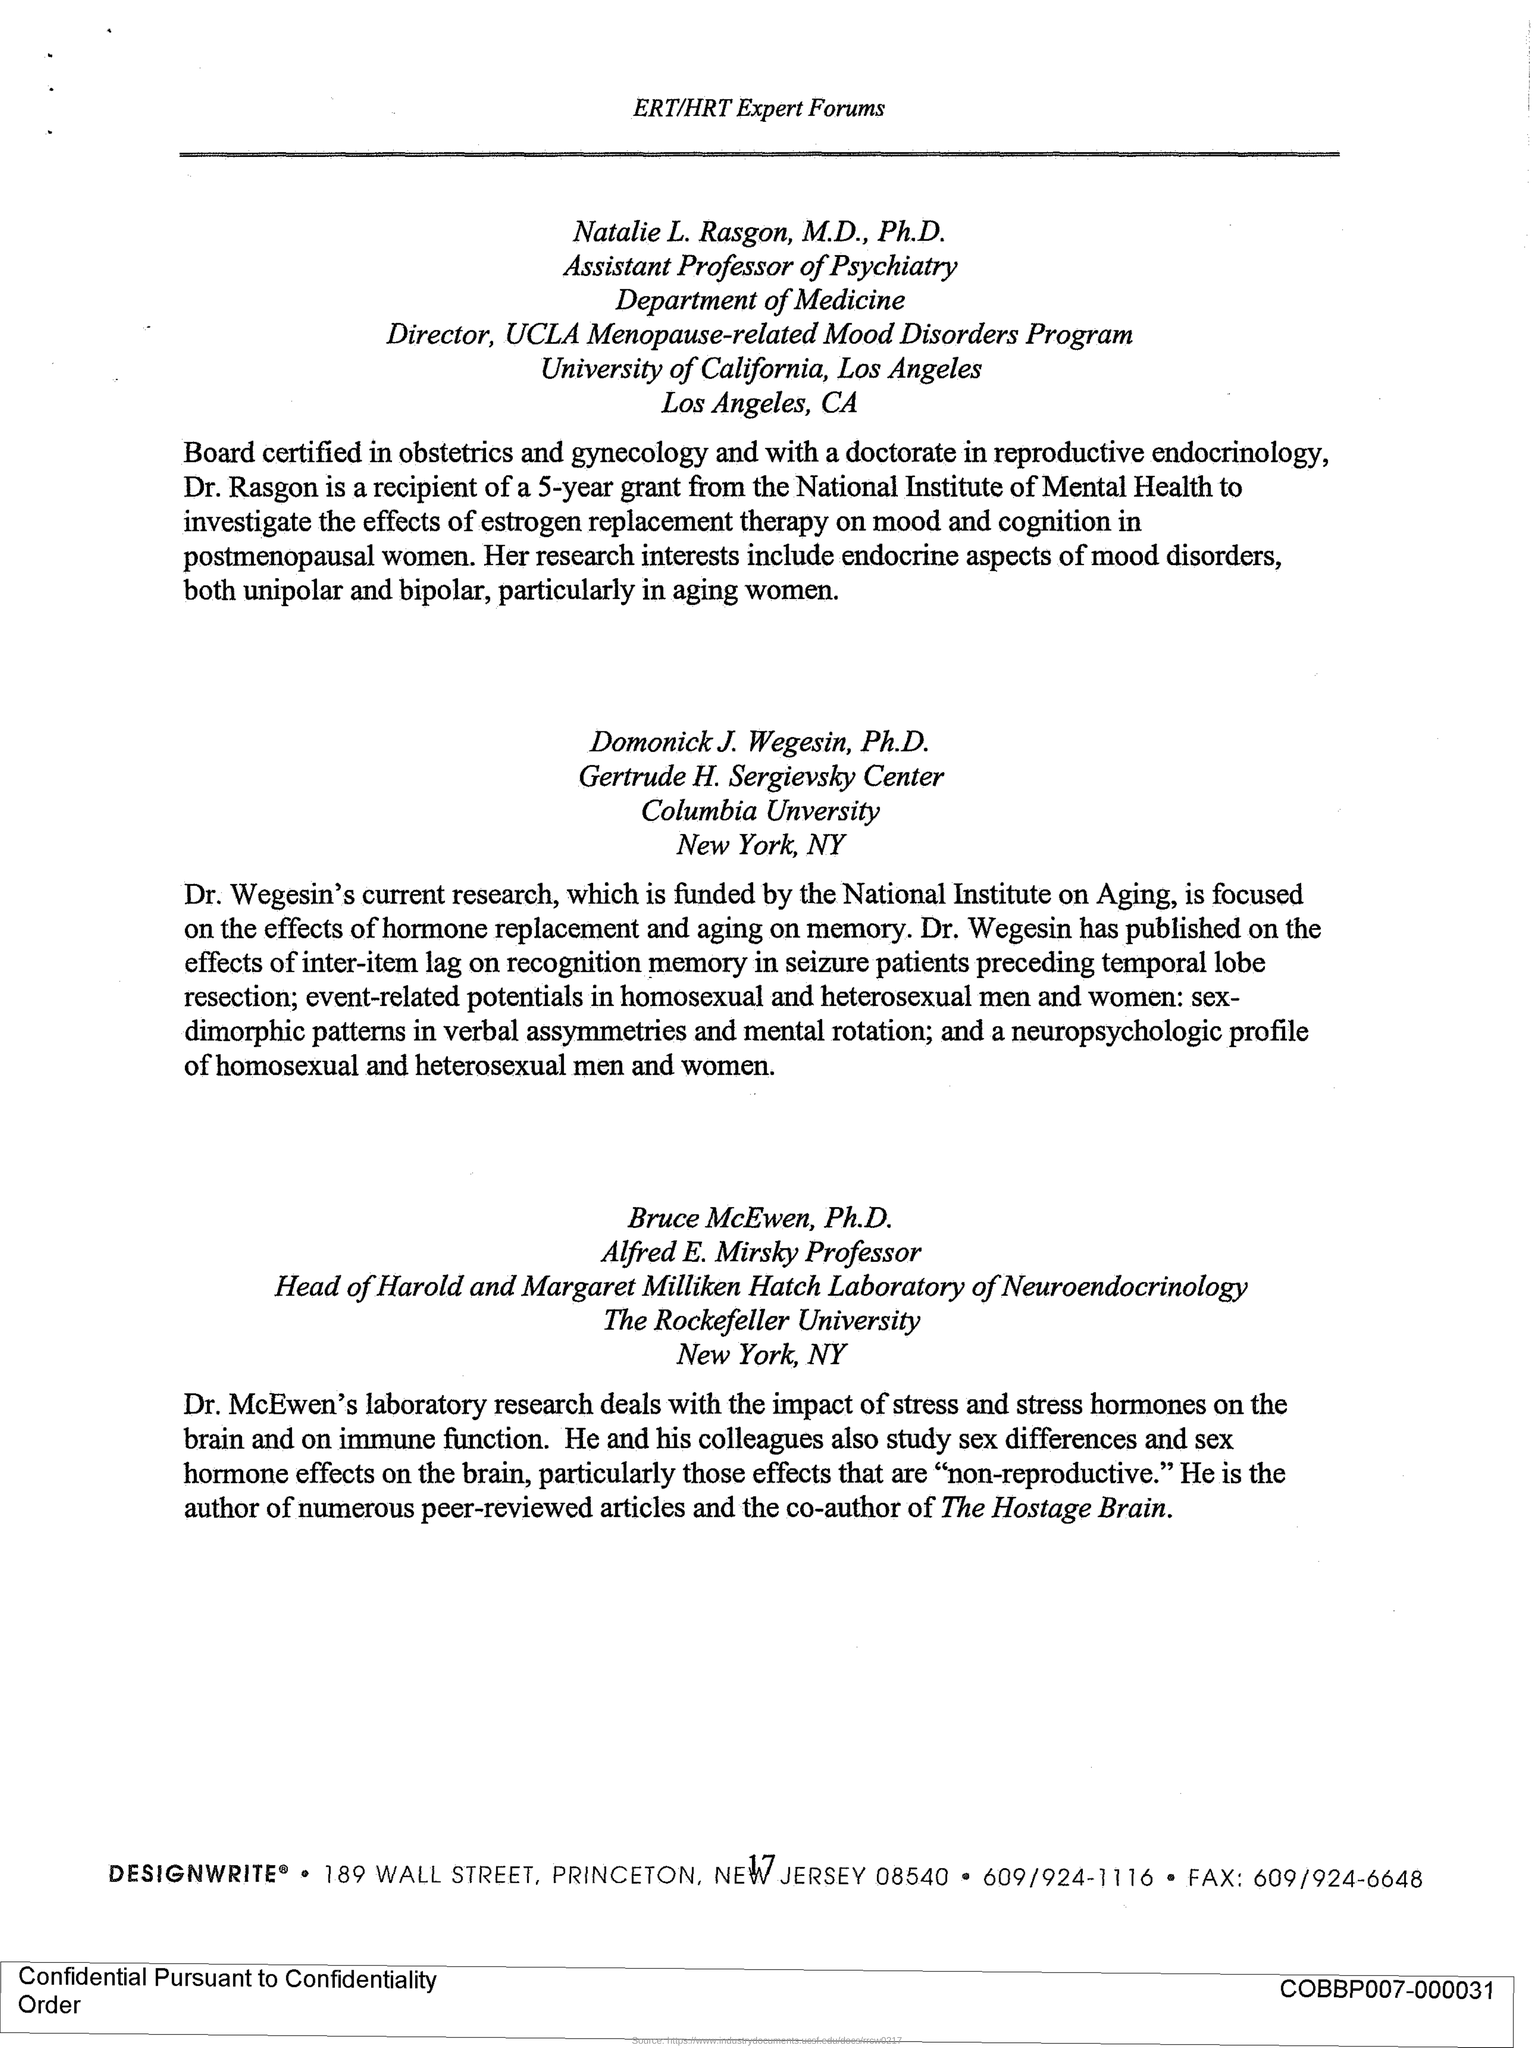What is the designation of Natalie L. Rasgon?
Offer a very short reply. Assistant professor of psychiatry. Which department Natalie L. Rasgon Work for?
Give a very brief answer. Department of medicine. Which University Natalie L. Rasagon work for?
Your response must be concise. University of california. Which city university of california is in?
Make the answer very short. LOS ANGELES. Dr. Rasagon is the recipient of 5 year grant to investigate from which institute?
Offer a terse response. National Institute of Mental Health. Which university is Dr. Wegesin's from?
Keep it short and to the point. Columbia university. Where is columbia university?
Offer a terse response. NEW YORK. Which university is Dr. McEwen from?
Keep it short and to the point. THE ROCKEFELLER UNIVERSITY. Dr. McEwen is the co-author of which article?
Offer a terse response. THE HOSTAGE BRAIN. 